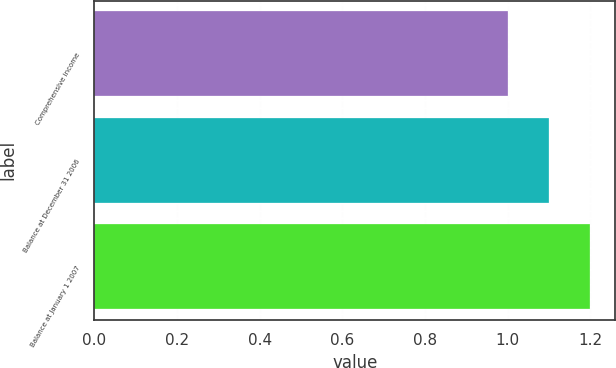Convert chart. <chart><loc_0><loc_0><loc_500><loc_500><bar_chart><fcel>Comprehensive income<fcel>Balance at December 31 2006<fcel>Balance at January 1 2007<nl><fcel>1<fcel>1.1<fcel>1.2<nl></chart> 